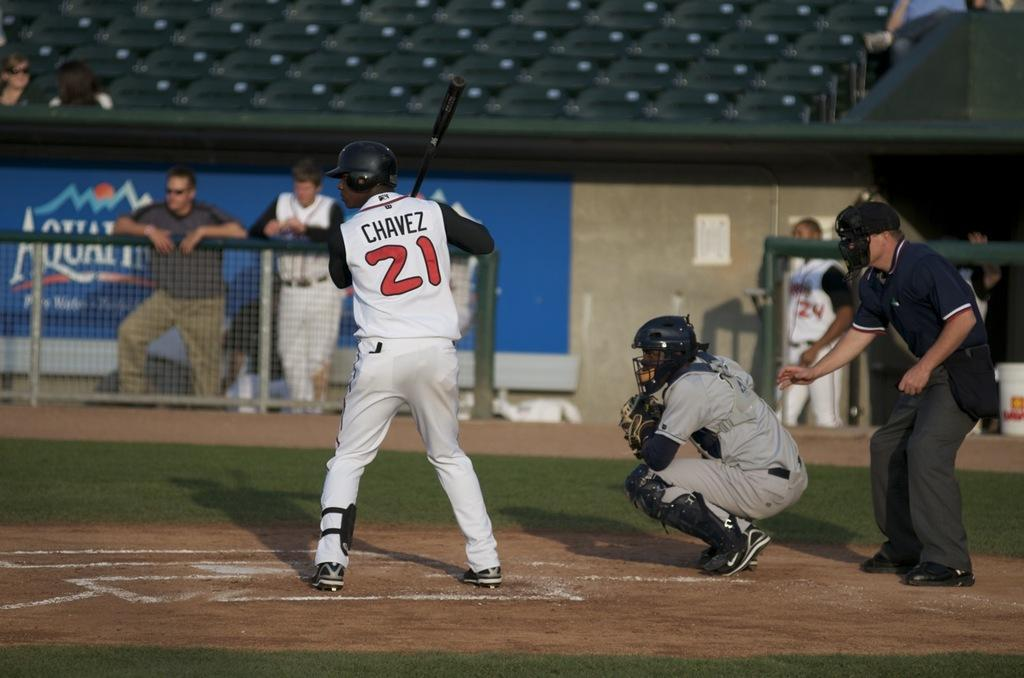<image>
Share a concise interpretation of the image provided. A baseball player at bat in a 21 jersey 